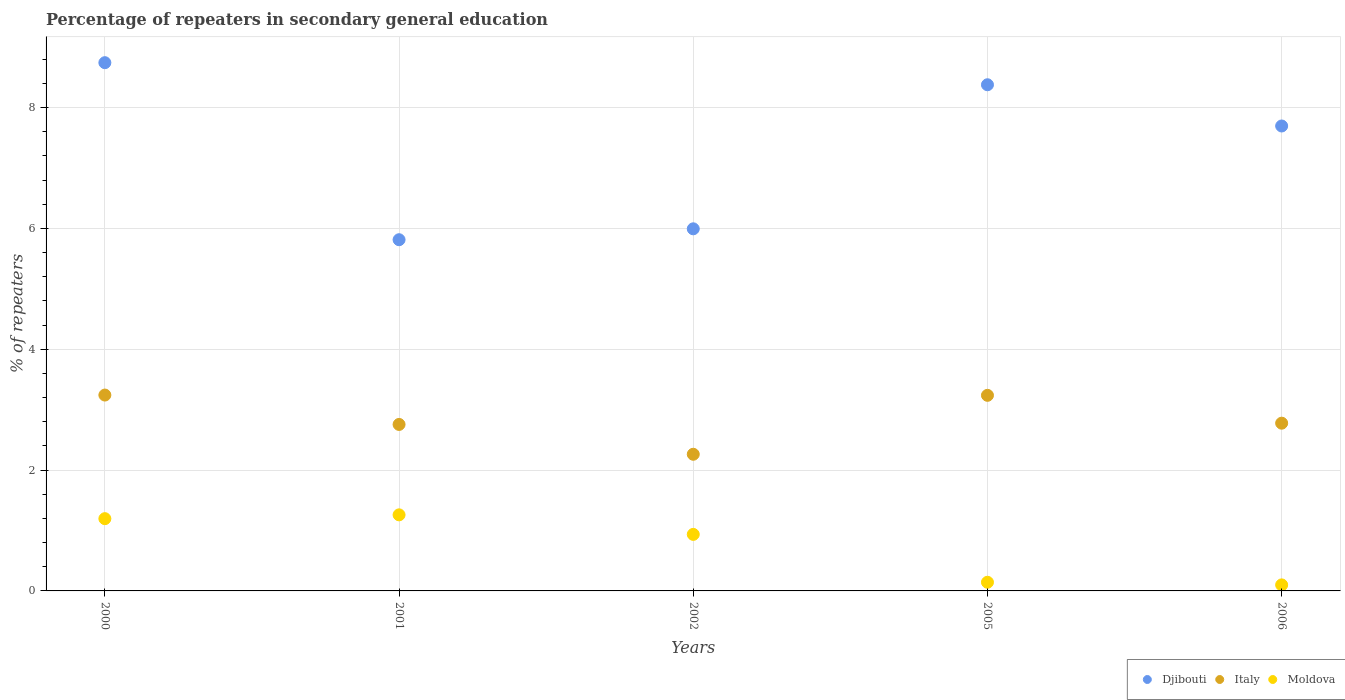How many different coloured dotlines are there?
Your answer should be very brief. 3. What is the percentage of repeaters in secondary general education in Djibouti in 2000?
Make the answer very short. 8.74. Across all years, what is the maximum percentage of repeaters in secondary general education in Italy?
Offer a very short reply. 3.24. Across all years, what is the minimum percentage of repeaters in secondary general education in Italy?
Offer a very short reply. 2.26. What is the total percentage of repeaters in secondary general education in Moldova in the graph?
Your answer should be very brief. 3.63. What is the difference between the percentage of repeaters in secondary general education in Djibouti in 2002 and that in 2005?
Your answer should be very brief. -2.38. What is the difference between the percentage of repeaters in secondary general education in Moldova in 2002 and the percentage of repeaters in secondary general education in Djibouti in 2005?
Your response must be concise. -7.44. What is the average percentage of repeaters in secondary general education in Moldova per year?
Ensure brevity in your answer.  0.73. In the year 2001, what is the difference between the percentage of repeaters in secondary general education in Moldova and percentage of repeaters in secondary general education in Italy?
Your answer should be compact. -1.5. In how many years, is the percentage of repeaters in secondary general education in Moldova greater than 5.2 %?
Provide a short and direct response. 0. What is the ratio of the percentage of repeaters in secondary general education in Djibouti in 2000 to that in 2001?
Give a very brief answer. 1.5. What is the difference between the highest and the second highest percentage of repeaters in secondary general education in Moldova?
Keep it short and to the point. 0.06. What is the difference between the highest and the lowest percentage of repeaters in secondary general education in Italy?
Your response must be concise. 0.98. In how many years, is the percentage of repeaters in secondary general education in Moldova greater than the average percentage of repeaters in secondary general education in Moldova taken over all years?
Keep it short and to the point. 3. Is the sum of the percentage of repeaters in secondary general education in Djibouti in 2002 and 2005 greater than the maximum percentage of repeaters in secondary general education in Moldova across all years?
Make the answer very short. Yes. Is it the case that in every year, the sum of the percentage of repeaters in secondary general education in Moldova and percentage of repeaters in secondary general education in Italy  is greater than the percentage of repeaters in secondary general education in Djibouti?
Keep it short and to the point. No. Is the percentage of repeaters in secondary general education in Djibouti strictly less than the percentage of repeaters in secondary general education in Moldova over the years?
Keep it short and to the point. No. How many years are there in the graph?
Provide a short and direct response. 5. What is the difference between two consecutive major ticks on the Y-axis?
Provide a short and direct response. 2. Does the graph contain grids?
Offer a terse response. Yes. How many legend labels are there?
Ensure brevity in your answer.  3. What is the title of the graph?
Give a very brief answer. Percentage of repeaters in secondary general education. What is the label or title of the Y-axis?
Offer a terse response. % of repeaters. What is the % of repeaters in Djibouti in 2000?
Your answer should be very brief. 8.74. What is the % of repeaters in Italy in 2000?
Provide a short and direct response. 3.24. What is the % of repeaters of Moldova in 2000?
Give a very brief answer. 1.2. What is the % of repeaters in Djibouti in 2001?
Ensure brevity in your answer.  5.81. What is the % of repeaters in Italy in 2001?
Make the answer very short. 2.76. What is the % of repeaters in Moldova in 2001?
Give a very brief answer. 1.26. What is the % of repeaters of Djibouti in 2002?
Provide a short and direct response. 5.99. What is the % of repeaters in Italy in 2002?
Offer a terse response. 2.26. What is the % of repeaters of Moldova in 2002?
Your answer should be very brief. 0.94. What is the % of repeaters of Djibouti in 2005?
Your answer should be compact. 8.38. What is the % of repeaters in Italy in 2005?
Your answer should be very brief. 3.24. What is the % of repeaters in Moldova in 2005?
Your answer should be compact. 0.14. What is the % of repeaters of Djibouti in 2006?
Provide a succinct answer. 7.7. What is the % of repeaters in Italy in 2006?
Make the answer very short. 2.78. What is the % of repeaters of Moldova in 2006?
Keep it short and to the point. 0.1. Across all years, what is the maximum % of repeaters of Djibouti?
Offer a very short reply. 8.74. Across all years, what is the maximum % of repeaters in Italy?
Make the answer very short. 3.24. Across all years, what is the maximum % of repeaters in Moldova?
Your response must be concise. 1.26. Across all years, what is the minimum % of repeaters of Djibouti?
Make the answer very short. 5.81. Across all years, what is the minimum % of repeaters of Italy?
Provide a short and direct response. 2.26. Across all years, what is the minimum % of repeaters of Moldova?
Give a very brief answer. 0.1. What is the total % of repeaters of Djibouti in the graph?
Your answer should be very brief. 36.63. What is the total % of repeaters in Italy in the graph?
Give a very brief answer. 14.27. What is the total % of repeaters in Moldova in the graph?
Keep it short and to the point. 3.63. What is the difference between the % of repeaters in Djibouti in 2000 and that in 2001?
Your answer should be very brief. 2.93. What is the difference between the % of repeaters in Italy in 2000 and that in 2001?
Offer a very short reply. 0.49. What is the difference between the % of repeaters in Moldova in 2000 and that in 2001?
Provide a short and direct response. -0.06. What is the difference between the % of repeaters of Djibouti in 2000 and that in 2002?
Make the answer very short. 2.75. What is the difference between the % of repeaters in Italy in 2000 and that in 2002?
Offer a very short reply. 0.98. What is the difference between the % of repeaters of Moldova in 2000 and that in 2002?
Provide a short and direct response. 0.26. What is the difference between the % of repeaters in Djibouti in 2000 and that in 2005?
Offer a very short reply. 0.37. What is the difference between the % of repeaters in Italy in 2000 and that in 2005?
Offer a very short reply. 0. What is the difference between the % of repeaters of Moldova in 2000 and that in 2005?
Offer a very short reply. 1.05. What is the difference between the % of repeaters in Djibouti in 2000 and that in 2006?
Keep it short and to the point. 1.05. What is the difference between the % of repeaters in Italy in 2000 and that in 2006?
Your response must be concise. 0.47. What is the difference between the % of repeaters in Moldova in 2000 and that in 2006?
Make the answer very short. 1.1. What is the difference between the % of repeaters in Djibouti in 2001 and that in 2002?
Your answer should be compact. -0.18. What is the difference between the % of repeaters of Italy in 2001 and that in 2002?
Offer a very short reply. 0.49. What is the difference between the % of repeaters in Moldova in 2001 and that in 2002?
Make the answer very short. 0.32. What is the difference between the % of repeaters in Djibouti in 2001 and that in 2005?
Your answer should be very brief. -2.56. What is the difference between the % of repeaters in Italy in 2001 and that in 2005?
Give a very brief answer. -0.48. What is the difference between the % of repeaters of Moldova in 2001 and that in 2005?
Give a very brief answer. 1.12. What is the difference between the % of repeaters of Djibouti in 2001 and that in 2006?
Your answer should be very brief. -1.88. What is the difference between the % of repeaters of Italy in 2001 and that in 2006?
Offer a terse response. -0.02. What is the difference between the % of repeaters in Moldova in 2001 and that in 2006?
Give a very brief answer. 1.16. What is the difference between the % of repeaters in Djibouti in 2002 and that in 2005?
Your response must be concise. -2.38. What is the difference between the % of repeaters in Italy in 2002 and that in 2005?
Offer a very short reply. -0.98. What is the difference between the % of repeaters in Moldova in 2002 and that in 2005?
Offer a very short reply. 0.79. What is the difference between the % of repeaters in Djibouti in 2002 and that in 2006?
Give a very brief answer. -1.7. What is the difference between the % of repeaters in Italy in 2002 and that in 2006?
Provide a short and direct response. -0.51. What is the difference between the % of repeaters of Moldova in 2002 and that in 2006?
Provide a succinct answer. 0.84. What is the difference between the % of repeaters of Djibouti in 2005 and that in 2006?
Your answer should be very brief. 0.68. What is the difference between the % of repeaters of Italy in 2005 and that in 2006?
Provide a succinct answer. 0.46. What is the difference between the % of repeaters in Moldova in 2005 and that in 2006?
Offer a terse response. 0.04. What is the difference between the % of repeaters in Djibouti in 2000 and the % of repeaters in Italy in 2001?
Provide a succinct answer. 5.99. What is the difference between the % of repeaters in Djibouti in 2000 and the % of repeaters in Moldova in 2001?
Your answer should be compact. 7.48. What is the difference between the % of repeaters of Italy in 2000 and the % of repeaters of Moldova in 2001?
Keep it short and to the point. 1.98. What is the difference between the % of repeaters in Djibouti in 2000 and the % of repeaters in Italy in 2002?
Keep it short and to the point. 6.48. What is the difference between the % of repeaters of Djibouti in 2000 and the % of repeaters of Moldova in 2002?
Provide a succinct answer. 7.81. What is the difference between the % of repeaters of Italy in 2000 and the % of repeaters of Moldova in 2002?
Make the answer very short. 2.31. What is the difference between the % of repeaters in Djibouti in 2000 and the % of repeaters in Italy in 2005?
Give a very brief answer. 5.51. What is the difference between the % of repeaters of Djibouti in 2000 and the % of repeaters of Moldova in 2005?
Give a very brief answer. 8.6. What is the difference between the % of repeaters in Italy in 2000 and the % of repeaters in Moldova in 2005?
Offer a very short reply. 3.1. What is the difference between the % of repeaters in Djibouti in 2000 and the % of repeaters in Italy in 2006?
Provide a succinct answer. 5.97. What is the difference between the % of repeaters of Djibouti in 2000 and the % of repeaters of Moldova in 2006?
Give a very brief answer. 8.64. What is the difference between the % of repeaters in Italy in 2000 and the % of repeaters in Moldova in 2006?
Offer a terse response. 3.14. What is the difference between the % of repeaters in Djibouti in 2001 and the % of repeaters in Italy in 2002?
Give a very brief answer. 3.55. What is the difference between the % of repeaters of Djibouti in 2001 and the % of repeaters of Moldova in 2002?
Ensure brevity in your answer.  4.88. What is the difference between the % of repeaters of Italy in 2001 and the % of repeaters of Moldova in 2002?
Provide a succinct answer. 1.82. What is the difference between the % of repeaters of Djibouti in 2001 and the % of repeaters of Italy in 2005?
Keep it short and to the point. 2.58. What is the difference between the % of repeaters of Djibouti in 2001 and the % of repeaters of Moldova in 2005?
Make the answer very short. 5.67. What is the difference between the % of repeaters of Italy in 2001 and the % of repeaters of Moldova in 2005?
Provide a short and direct response. 2.61. What is the difference between the % of repeaters of Djibouti in 2001 and the % of repeaters of Italy in 2006?
Ensure brevity in your answer.  3.04. What is the difference between the % of repeaters in Djibouti in 2001 and the % of repeaters in Moldova in 2006?
Offer a terse response. 5.71. What is the difference between the % of repeaters in Italy in 2001 and the % of repeaters in Moldova in 2006?
Ensure brevity in your answer.  2.66. What is the difference between the % of repeaters of Djibouti in 2002 and the % of repeaters of Italy in 2005?
Provide a short and direct response. 2.76. What is the difference between the % of repeaters in Djibouti in 2002 and the % of repeaters in Moldova in 2005?
Offer a very short reply. 5.85. What is the difference between the % of repeaters of Italy in 2002 and the % of repeaters of Moldova in 2005?
Your response must be concise. 2.12. What is the difference between the % of repeaters in Djibouti in 2002 and the % of repeaters in Italy in 2006?
Offer a terse response. 3.22. What is the difference between the % of repeaters of Djibouti in 2002 and the % of repeaters of Moldova in 2006?
Give a very brief answer. 5.89. What is the difference between the % of repeaters in Italy in 2002 and the % of repeaters in Moldova in 2006?
Your answer should be very brief. 2.16. What is the difference between the % of repeaters of Djibouti in 2005 and the % of repeaters of Italy in 2006?
Offer a terse response. 5.6. What is the difference between the % of repeaters in Djibouti in 2005 and the % of repeaters in Moldova in 2006?
Make the answer very short. 8.28. What is the difference between the % of repeaters of Italy in 2005 and the % of repeaters of Moldova in 2006?
Your answer should be compact. 3.14. What is the average % of repeaters of Djibouti per year?
Offer a terse response. 7.33. What is the average % of repeaters of Italy per year?
Make the answer very short. 2.85. What is the average % of repeaters in Moldova per year?
Provide a short and direct response. 0.73. In the year 2000, what is the difference between the % of repeaters of Djibouti and % of repeaters of Italy?
Provide a short and direct response. 5.5. In the year 2000, what is the difference between the % of repeaters in Djibouti and % of repeaters in Moldova?
Ensure brevity in your answer.  7.55. In the year 2000, what is the difference between the % of repeaters in Italy and % of repeaters in Moldova?
Ensure brevity in your answer.  2.05. In the year 2001, what is the difference between the % of repeaters of Djibouti and % of repeaters of Italy?
Your answer should be very brief. 3.06. In the year 2001, what is the difference between the % of repeaters in Djibouti and % of repeaters in Moldova?
Make the answer very short. 4.55. In the year 2001, what is the difference between the % of repeaters in Italy and % of repeaters in Moldova?
Your answer should be very brief. 1.5. In the year 2002, what is the difference between the % of repeaters of Djibouti and % of repeaters of Italy?
Give a very brief answer. 3.73. In the year 2002, what is the difference between the % of repeaters of Djibouti and % of repeaters of Moldova?
Make the answer very short. 5.06. In the year 2002, what is the difference between the % of repeaters of Italy and % of repeaters of Moldova?
Your answer should be compact. 1.33. In the year 2005, what is the difference between the % of repeaters in Djibouti and % of repeaters in Italy?
Your answer should be compact. 5.14. In the year 2005, what is the difference between the % of repeaters in Djibouti and % of repeaters in Moldova?
Ensure brevity in your answer.  8.24. In the year 2005, what is the difference between the % of repeaters in Italy and % of repeaters in Moldova?
Your answer should be very brief. 3.09. In the year 2006, what is the difference between the % of repeaters in Djibouti and % of repeaters in Italy?
Your answer should be very brief. 4.92. In the year 2006, what is the difference between the % of repeaters in Djibouti and % of repeaters in Moldova?
Make the answer very short. 7.6. In the year 2006, what is the difference between the % of repeaters of Italy and % of repeaters of Moldova?
Offer a very short reply. 2.68. What is the ratio of the % of repeaters of Djibouti in 2000 to that in 2001?
Provide a succinct answer. 1.5. What is the ratio of the % of repeaters in Italy in 2000 to that in 2001?
Your answer should be very brief. 1.18. What is the ratio of the % of repeaters in Moldova in 2000 to that in 2001?
Provide a succinct answer. 0.95. What is the ratio of the % of repeaters in Djibouti in 2000 to that in 2002?
Ensure brevity in your answer.  1.46. What is the ratio of the % of repeaters in Italy in 2000 to that in 2002?
Your response must be concise. 1.43. What is the ratio of the % of repeaters of Moldova in 2000 to that in 2002?
Your response must be concise. 1.28. What is the ratio of the % of repeaters in Djibouti in 2000 to that in 2005?
Offer a terse response. 1.04. What is the ratio of the % of repeaters in Moldova in 2000 to that in 2005?
Offer a terse response. 8.34. What is the ratio of the % of repeaters in Djibouti in 2000 to that in 2006?
Provide a short and direct response. 1.14. What is the ratio of the % of repeaters of Italy in 2000 to that in 2006?
Make the answer very short. 1.17. What is the ratio of the % of repeaters of Moldova in 2000 to that in 2006?
Offer a very short reply. 11.98. What is the ratio of the % of repeaters in Djibouti in 2001 to that in 2002?
Provide a succinct answer. 0.97. What is the ratio of the % of repeaters in Italy in 2001 to that in 2002?
Offer a terse response. 1.22. What is the ratio of the % of repeaters in Moldova in 2001 to that in 2002?
Your answer should be very brief. 1.35. What is the ratio of the % of repeaters of Djibouti in 2001 to that in 2005?
Keep it short and to the point. 0.69. What is the ratio of the % of repeaters of Italy in 2001 to that in 2005?
Offer a very short reply. 0.85. What is the ratio of the % of repeaters of Moldova in 2001 to that in 2005?
Your response must be concise. 8.78. What is the ratio of the % of repeaters of Djibouti in 2001 to that in 2006?
Offer a very short reply. 0.76. What is the ratio of the % of repeaters of Moldova in 2001 to that in 2006?
Make the answer very short. 12.61. What is the ratio of the % of repeaters of Djibouti in 2002 to that in 2005?
Your answer should be very brief. 0.72. What is the ratio of the % of repeaters in Italy in 2002 to that in 2005?
Keep it short and to the point. 0.7. What is the ratio of the % of repeaters of Moldova in 2002 to that in 2005?
Make the answer very short. 6.53. What is the ratio of the % of repeaters of Djibouti in 2002 to that in 2006?
Provide a short and direct response. 0.78. What is the ratio of the % of repeaters of Italy in 2002 to that in 2006?
Keep it short and to the point. 0.81. What is the ratio of the % of repeaters of Moldova in 2002 to that in 2006?
Ensure brevity in your answer.  9.37. What is the ratio of the % of repeaters in Djibouti in 2005 to that in 2006?
Provide a succinct answer. 1.09. What is the ratio of the % of repeaters in Italy in 2005 to that in 2006?
Keep it short and to the point. 1.17. What is the ratio of the % of repeaters of Moldova in 2005 to that in 2006?
Provide a succinct answer. 1.44. What is the difference between the highest and the second highest % of repeaters of Djibouti?
Offer a very short reply. 0.37. What is the difference between the highest and the second highest % of repeaters in Italy?
Your response must be concise. 0. What is the difference between the highest and the second highest % of repeaters in Moldova?
Keep it short and to the point. 0.06. What is the difference between the highest and the lowest % of repeaters of Djibouti?
Provide a short and direct response. 2.93. What is the difference between the highest and the lowest % of repeaters in Italy?
Offer a terse response. 0.98. What is the difference between the highest and the lowest % of repeaters in Moldova?
Ensure brevity in your answer.  1.16. 